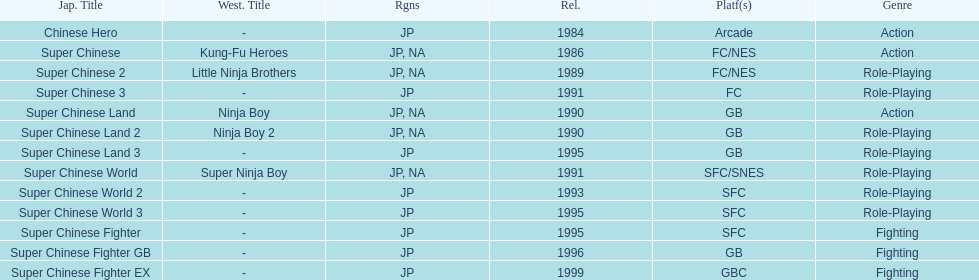Number of super chinese world games released 3. 